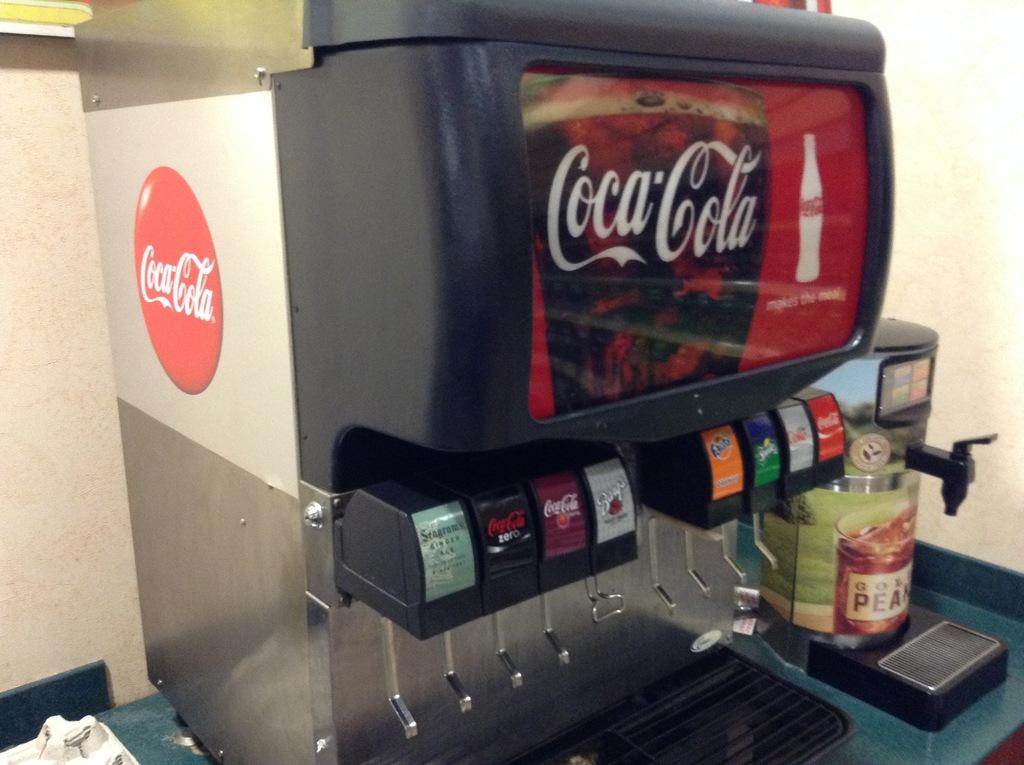What kind of soda machine is this?
Ensure brevity in your answer.  Coca-cola. Does this machine dispense fanta?
Make the answer very short. Yes. 